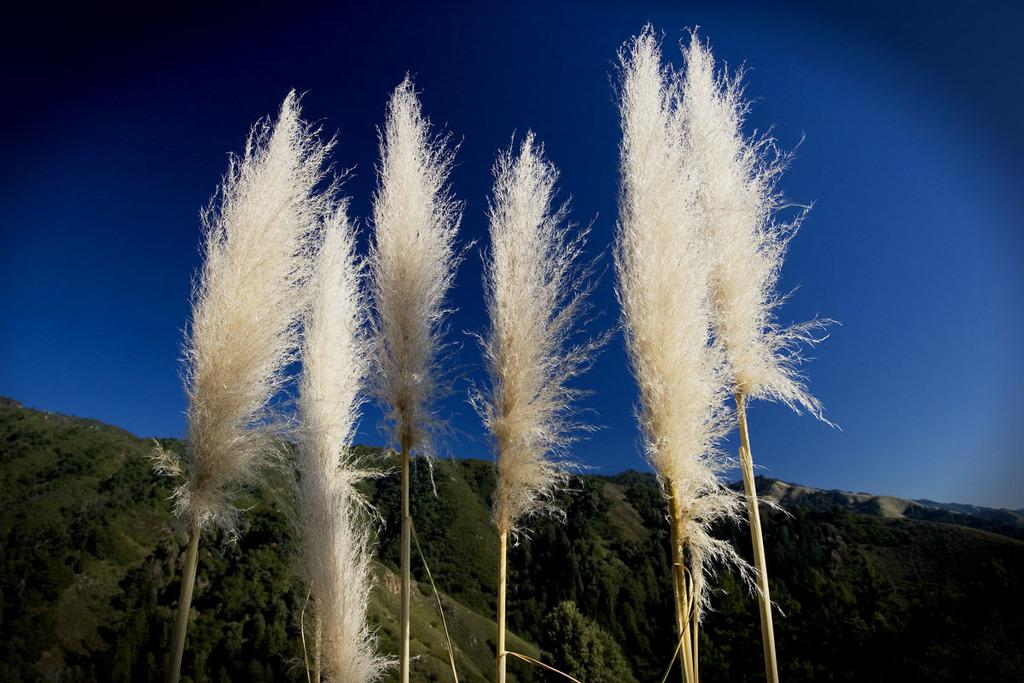What type of vegetation can be seen in the image? There are trees in the image. What is the color of the trees? The trees are cream in color. What can be seen in the distance behind the trees? There are mountains in the background of the image. Are there trees on the mountains as well? Yes, there are trees on the mountains. What else is visible in the background of the image? The sky is visible in the background of the image. What type of sign can be seen on the trees in the image? There are no signs visible on the trees in the image. How does the image indicate that the trees should stop growing? The image does not indicate that the trees should stop growing, nor does it contain any stop signs or similar elements. 